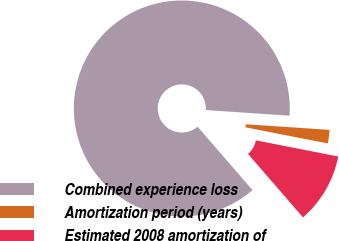Convert chart to OTSL. <chart><loc_0><loc_0><loc_500><loc_500><pie_chart><fcel>Combined experience loss<fcel>Amortization period (years)<fcel>Estimated 2008 amortization of<nl><fcel>87.43%<fcel>2.02%<fcel>10.56%<nl></chart> 